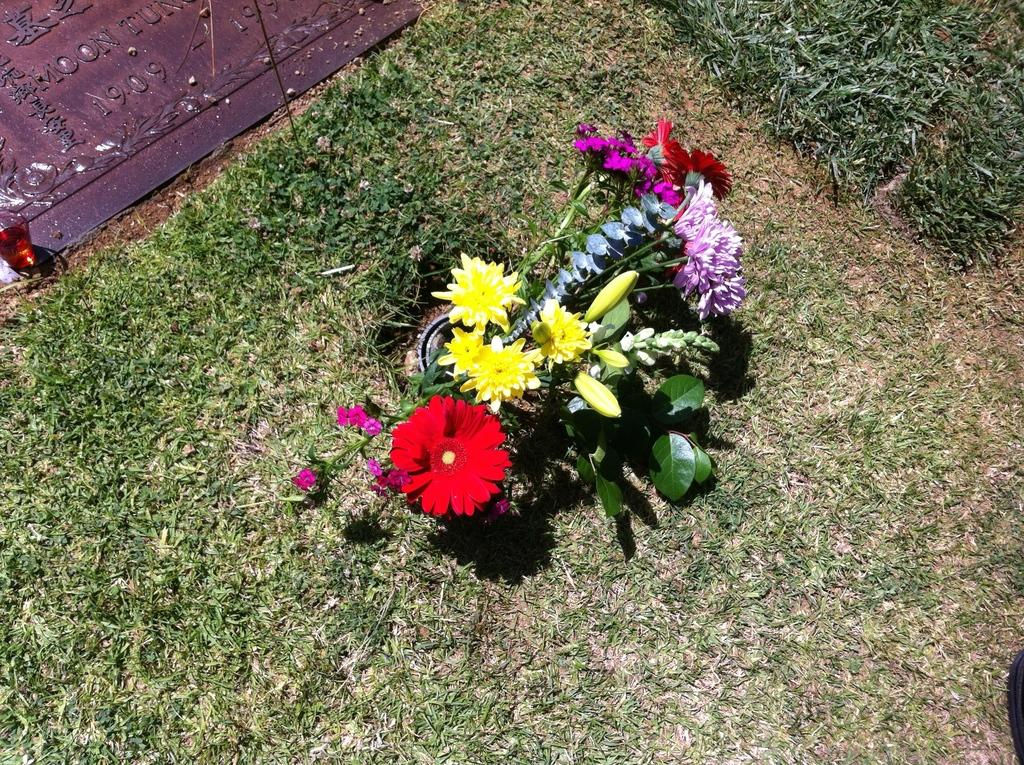What types of flowers can be seen in the image? There are flowers of different colors in the image, including red, yellow, and purple. What color are the leaves of the flowers? The leaves in the image are green. What type of vegetation is present in the image? There is green grass in the image. Is there any text or writing visible in the image? Yes, there is text or writing visible in the image. What level of grass is visible in the image? There is no indication of a "level" of grass in the image; it simply shows green grass. Can you see the person's dad in the image? There is no person or dad present in the image; it features flowers, leaves, grass, and text or writing. 